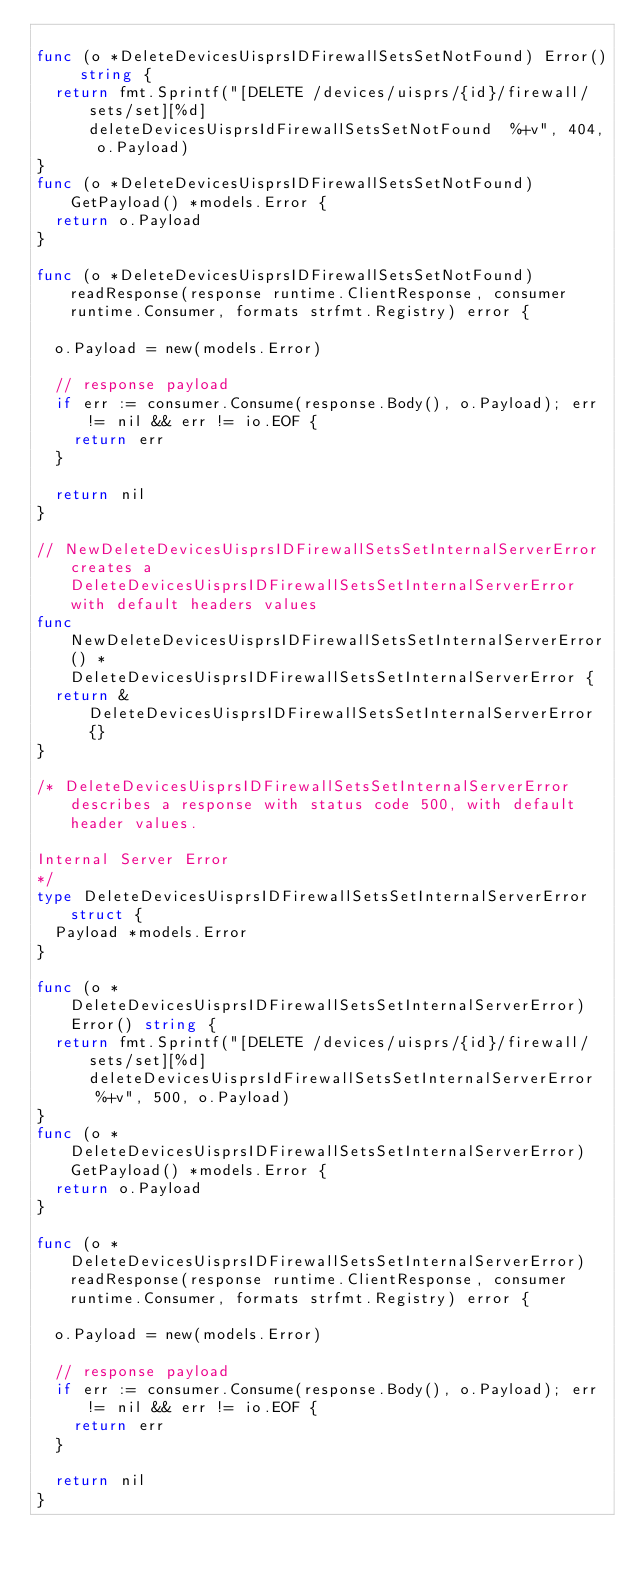Convert code to text. <code><loc_0><loc_0><loc_500><loc_500><_Go_>
func (o *DeleteDevicesUisprsIDFirewallSetsSetNotFound) Error() string {
	return fmt.Sprintf("[DELETE /devices/uisprs/{id}/firewall/sets/set][%d] deleteDevicesUisprsIdFirewallSetsSetNotFound  %+v", 404, o.Payload)
}
func (o *DeleteDevicesUisprsIDFirewallSetsSetNotFound) GetPayload() *models.Error {
	return o.Payload
}

func (o *DeleteDevicesUisprsIDFirewallSetsSetNotFound) readResponse(response runtime.ClientResponse, consumer runtime.Consumer, formats strfmt.Registry) error {

	o.Payload = new(models.Error)

	// response payload
	if err := consumer.Consume(response.Body(), o.Payload); err != nil && err != io.EOF {
		return err
	}

	return nil
}

// NewDeleteDevicesUisprsIDFirewallSetsSetInternalServerError creates a DeleteDevicesUisprsIDFirewallSetsSetInternalServerError with default headers values
func NewDeleteDevicesUisprsIDFirewallSetsSetInternalServerError() *DeleteDevicesUisprsIDFirewallSetsSetInternalServerError {
	return &DeleteDevicesUisprsIDFirewallSetsSetInternalServerError{}
}

/* DeleteDevicesUisprsIDFirewallSetsSetInternalServerError describes a response with status code 500, with default header values.

Internal Server Error
*/
type DeleteDevicesUisprsIDFirewallSetsSetInternalServerError struct {
	Payload *models.Error
}

func (o *DeleteDevicesUisprsIDFirewallSetsSetInternalServerError) Error() string {
	return fmt.Sprintf("[DELETE /devices/uisprs/{id}/firewall/sets/set][%d] deleteDevicesUisprsIdFirewallSetsSetInternalServerError  %+v", 500, o.Payload)
}
func (o *DeleteDevicesUisprsIDFirewallSetsSetInternalServerError) GetPayload() *models.Error {
	return o.Payload
}

func (o *DeleteDevicesUisprsIDFirewallSetsSetInternalServerError) readResponse(response runtime.ClientResponse, consumer runtime.Consumer, formats strfmt.Registry) error {

	o.Payload = new(models.Error)

	// response payload
	if err := consumer.Consume(response.Body(), o.Payload); err != nil && err != io.EOF {
		return err
	}

	return nil
}
</code> 